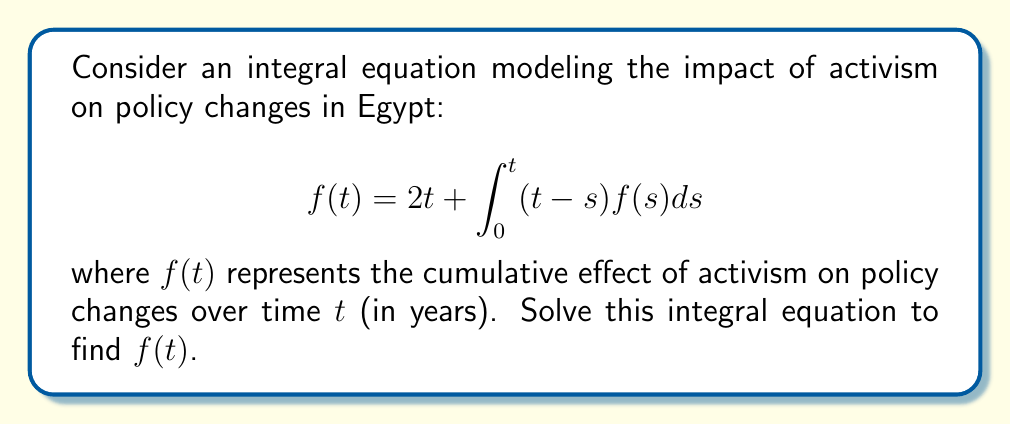Give your solution to this math problem. To solve this integral equation, we'll follow these steps:

1) First, we differentiate both sides of the equation with respect to $t$:

   $$f'(t) = 2 + \int_0^t f(s)ds + (t-t)f(t) = 2 + \int_0^t f(s)ds$$

2) Differentiate again:

   $$f''(t) = f(t)$$

3) This is a second-order differential equation. The general solution is:

   $$f(t) = c_1e^t + c_2e^{-t}$$

4) To find $c_1$ and $c_2$, we use the initial conditions:

   At $t=0$: $f(0) = 2(0) + \int_0^0 (0-s)f(s)ds = 0$
   
   So, $c_1 + c_2 = 0$

5) We also need $f'(0)$:

   $f'(0) = 2 + \int_0^0 f(s)ds = 2$
   
   So, $c_1 - c_2 = 2$

6) Solving these equations:

   $c_1 = 1$ and $c_2 = -1$

7) Therefore, the solution is:

   $$f(t) = e^t - e^{-t} = 2\sinh(t)$$

This solution represents how the cumulative effect of activism on policy changes grows over time, with an initial rapid increase that gradually slows down.
Answer: $f(t) = 2\sinh(t)$ 